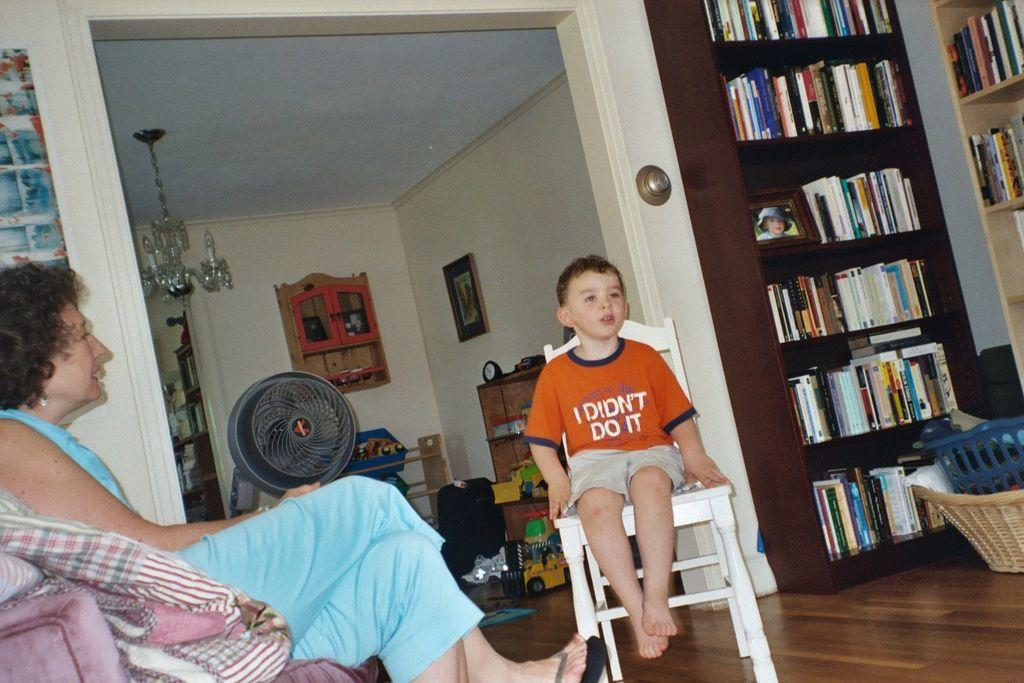<image>
Share a concise interpretation of the image provided. A boy wearing a shirt that says "I didn't do it" is sitting on a chair. 